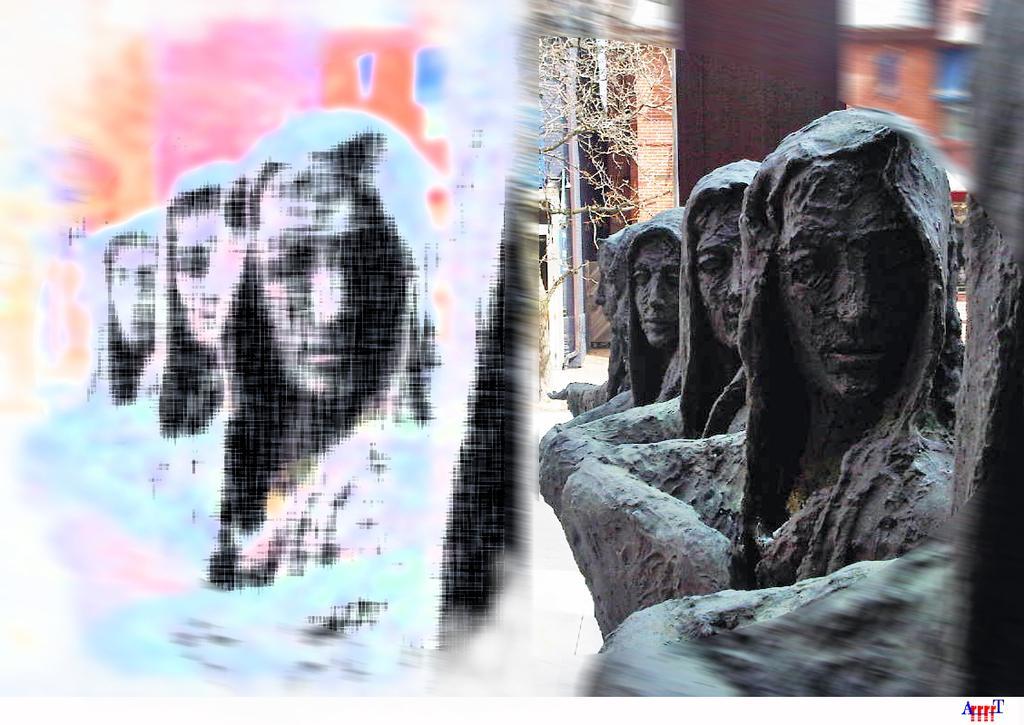Describe this image in one or two sentences. In this image we can see statues on the right side. In the back there is a building. Also there is a tree. On the left side of the image there is a photo effect. 